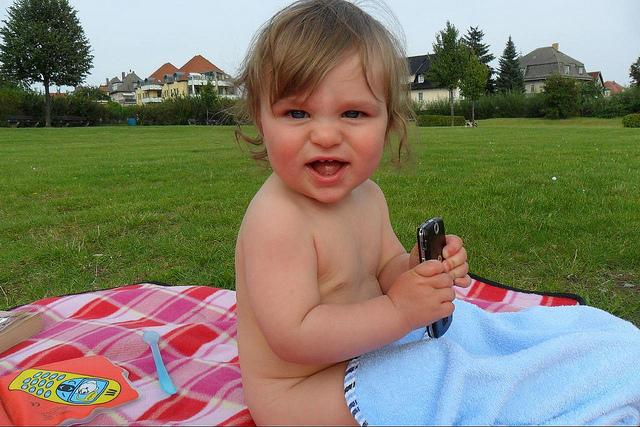What fairly important item is missing from this child? Please explain your reasoning. diaper. Most babies at this age need diapers. 